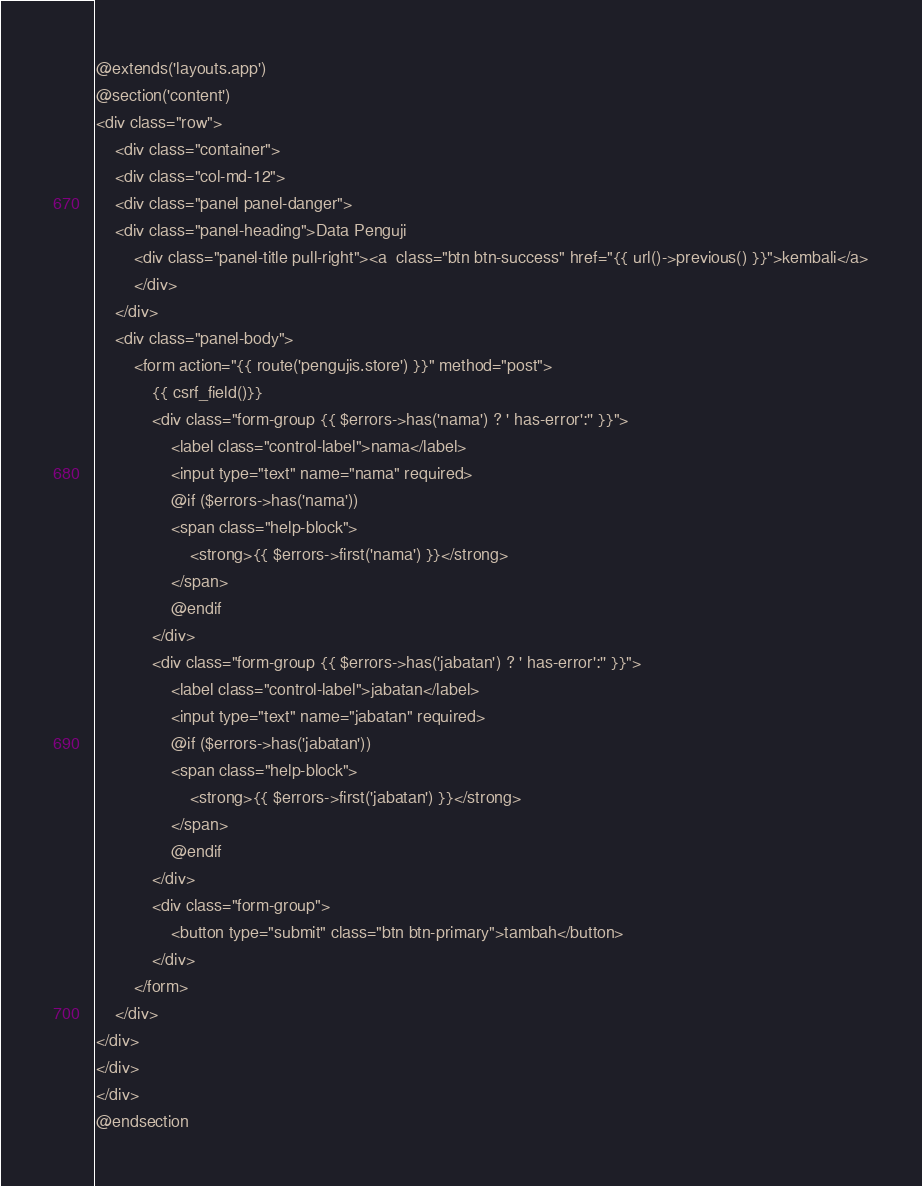<code> <loc_0><loc_0><loc_500><loc_500><_PHP_>@extends('layouts.app')
@section('content')
<div class="row">
	<div class="container">
	<div class="col-md-12">
	<div class="panel panel-danger">
    <div class="panel-heading">Data Penguji
    	<div class="panel-title pull-right"><a  class="btn btn-success" href="{{ url()->previous() }}">kembali</a>
    	</div>
    </div>
    <div class="panel-body">
    	<form action="{{ route('pengujis.store') }}" method="post">
    		{{ csrf_field()}}
    		<div class="form-group {{ $errors->has('nama') ? ' has-error':'' }}">
    			<label class="control-label">nama</label>
    			<input type="text" name="nama" required>
    			@if ($errors->has('nama'))
    			<span class="help-block">
    				<strong>{{ $errors->first('nama') }}</strong>
    			</span>
    			@endif
    		</div>
            <div class="form-group {{ $errors->has('jabatan') ? ' has-error':'' }}">
                <label class="control-label">jabatan</label>
                <input type="text" name="jabatan" required>
                @if ($errors->has('jabatan'))
                <span class="help-block">
                    <strong>{{ $errors->first('jabatan') }}</strong>
                </span>
                @endif
            </div>
    		<div class="form-group">
    			<button type="submit" class="btn btn-primary">tambah</button>
    		</div>
    	</form>
    </div>
</div>
</div>
</div>
@endsection</code> 